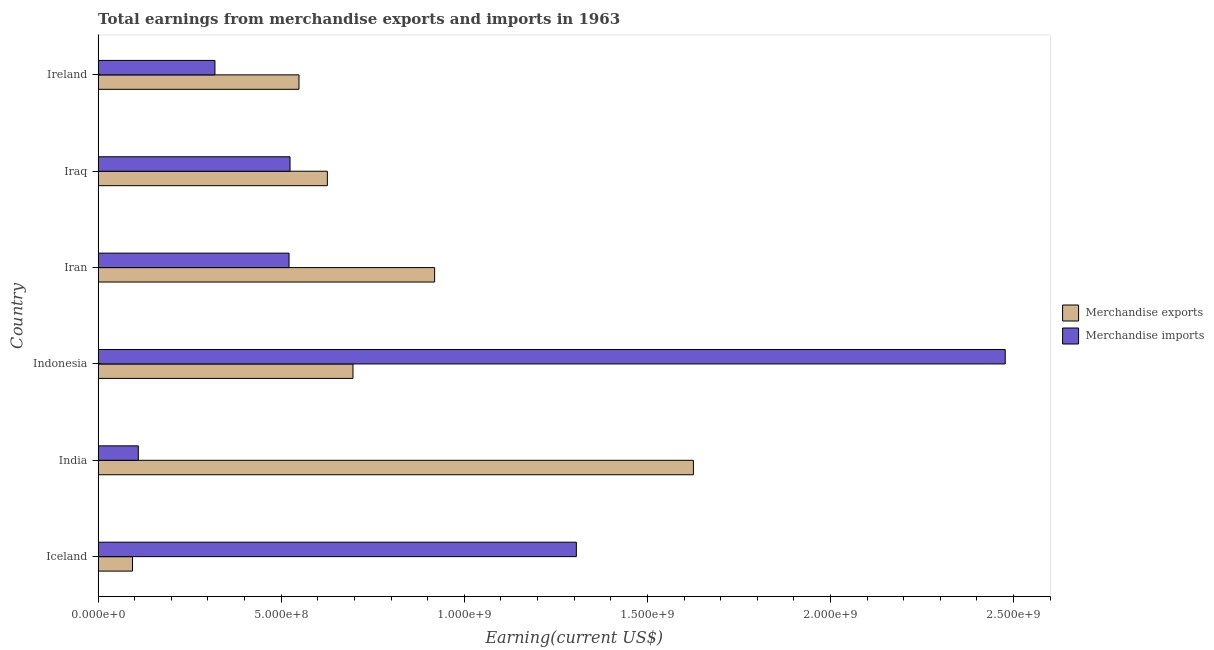Are the number of bars per tick equal to the number of legend labels?
Keep it short and to the point. Yes. How many bars are there on the 4th tick from the top?
Provide a short and direct response. 2. In how many cases, is the number of bars for a given country not equal to the number of legend labels?
Your response must be concise. 0. What is the earnings from merchandise exports in India?
Offer a very short reply. 1.63e+09. Across all countries, what is the maximum earnings from merchandise exports?
Offer a very short reply. 1.63e+09. Across all countries, what is the minimum earnings from merchandise imports?
Ensure brevity in your answer.  1.10e+08. What is the total earnings from merchandise exports in the graph?
Ensure brevity in your answer.  4.51e+09. What is the difference between the earnings from merchandise imports in Iran and that in Iraq?
Your answer should be very brief. -2.69e+06. What is the difference between the earnings from merchandise imports in Iceland and the earnings from merchandise exports in Iraq?
Provide a short and direct response. 6.80e+08. What is the average earnings from merchandise imports per country?
Ensure brevity in your answer.  8.76e+08. What is the difference between the earnings from merchandise imports and earnings from merchandise exports in Iraq?
Keep it short and to the point. -1.02e+08. In how many countries, is the earnings from merchandise exports greater than 600000000 US$?
Keep it short and to the point. 4. What is the ratio of the earnings from merchandise exports in India to that in Ireland?
Your response must be concise. 2.96. What is the difference between the highest and the second highest earnings from merchandise exports?
Your answer should be compact. 7.07e+08. What is the difference between the highest and the lowest earnings from merchandise imports?
Offer a very short reply. 2.37e+09. Is the sum of the earnings from merchandise imports in India and Iraq greater than the maximum earnings from merchandise exports across all countries?
Provide a short and direct response. No. What does the 1st bar from the bottom in India represents?
Offer a terse response. Merchandise exports. How many bars are there?
Offer a terse response. 12. Are all the bars in the graph horizontal?
Your response must be concise. Yes. Does the graph contain any zero values?
Provide a succinct answer. No. Does the graph contain grids?
Offer a very short reply. No. How are the legend labels stacked?
Offer a very short reply. Vertical. What is the title of the graph?
Give a very brief answer. Total earnings from merchandise exports and imports in 1963. What is the label or title of the X-axis?
Your response must be concise. Earning(current US$). What is the Earning(current US$) in Merchandise exports in Iceland?
Offer a very short reply. 9.40e+07. What is the Earning(current US$) in Merchandise imports in Iceland?
Provide a succinct answer. 1.31e+09. What is the Earning(current US$) of Merchandise exports in India?
Make the answer very short. 1.63e+09. What is the Earning(current US$) in Merchandise imports in India?
Provide a succinct answer. 1.10e+08. What is the Earning(current US$) of Merchandise exports in Indonesia?
Provide a succinct answer. 6.96e+08. What is the Earning(current US$) in Merchandise imports in Indonesia?
Your answer should be very brief. 2.48e+09. What is the Earning(current US$) of Merchandise exports in Iran?
Provide a succinct answer. 9.19e+08. What is the Earning(current US$) in Merchandise imports in Iran?
Provide a short and direct response. 5.21e+08. What is the Earning(current US$) in Merchandise exports in Iraq?
Ensure brevity in your answer.  6.26e+08. What is the Earning(current US$) in Merchandise imports in Iraq?
Ensure brevity in your answer.  5.24e+08. What is the Earning(current US$) in Merchandise exports in Ireland?
Give a very brief answer. 5.49e+08. What is the Earning(current US$) of Merchandise imports in Ireland?
Your response must be concise. 3.19e+08. Across all countries, what is the maximum Earning(current US$) of Merchandise exports?
Provide a succinct answer. 1.63e+09. Across all countries, what is the maximum Earning(current US$) of Merchandise imports?
Keep it short and to the point. 2.48e+09. Across all countries, what is the minimum Earning(current US$) in Merchandise exports?
Keep it short and to the point. 9.40e+07. Across all countries, what is the minimum Earning(current US$) of Merchandise imports?
Give a very brief answer. 1.10e+08. What is the total Earning(current US$) in Merchandise exports in the graph?
Ensure brevity in your answer.  4.51e+09. What is the total Earning(current US$) in Merchandise imports in the graph?
Offer a terse response. 5.26e+09. What is the difference between the Earning(current US$) in Merchandise exports in Iceland and that in India?
Make the answer very short. -1.53e+09. What is the difference between the Earning(current US$) of Merchandise imports in Iceland and that in India?
Provide a succinct answer. 1.20e+09. What is the difference between the Earning(current US$) in Merchandise exports in Iceland and that in Indonesia?
Keep it short and to the point. -6.02e+08. What is the difference between the Earning(current US$) in Merchandise imports in Iceland and that in Indonesia?
Offer a terse response. -1.17e+09. What is the difference between the Earning(current US$) in Merchandise exports in Iceland and that in Iran?
Offer a very short reply. -8.25e+08. What is the difference between the Earning(current US$) in Merchandise imports in Iceland and that in Iran?
Give a very brief answer. 7.85e+08. What is the difference between the Earning(current US$) in Merchandise exports in Iceland and that in Iraq?
Provide a short and direct response. -5.32e+08. What is the difference between the Earning(current US$) in Merchandise imports in Iceland and that in Iraq?
Your answer should be very brief. 7.82e+08. What is the difference between the Earning(current US$) in Merchandise exports in Iceland and that in Ireland?
Your answer should be very brief. -4.55e+08. What is the difference between the Earning(current US$) of Merchandise imports in Iceland and that in Ireland?
Provide a short and direct response. 9.87e+08. What is the difference between the Earning(current US$) of Merchandise exports in India and that in Indonesia?
Give a very brief answer. 9.30e+08. What is the difference between the Earning(current US$) in Merchandise imports in India and that in Indonesia?
Make the answer very short. -2.37e+09. What is the difference between the Earning(current US$) in Merchandise exports in India and that in Iran?
Provide a short and direct response. 7.07e+08. What is the difference between the Earning(current US$) in Merchandise imports in India and that in Iran?
Make the answer very short. -4.12e+08. What is the difference between the Earning(current US$) of Merchandise exports in India and that in Iraq?
Your answer should be very brief. 1.00e+09. What is the difference between the Earning(current US$) in Merchandise imports in India and that in Iraq?
Ensure brevity in your answer.  -4.14e+08. What is the difference between the Earning(current US$) of Merchandise exports in India and that in Ireland?
Offer a very short reply. 1.08e+09. What is the difference between the Earning(current US$) in Merchandise imports in India and that in Ireland?
Offer a very short reply. -2.09e+08. What is the difference between the Earning(current US$) of Merchandise exports in Indonesia and that in Iran?
Provide a succinct answer. -2.23e+08. What is the difference between the Earning(current US$) in Merchandise imports in Indonesia and that in Iran?
Make the answer very short. 1.96e+09. What is the difference between the Earning(current US$) of Merchandise exports in Indonesia and that in Iraq?
Offer a terse response. 7.00e+07. What is the difference between the Earning(current US$) in Merchandise imports in Indonesia and that in Iraq?
Provide a short and direct response. 1.95e+09. What is the difference between the Earning(current US$) in Merchandise exports in Indonesia and that in Ireland?
Ensure brevity in your answer.  1.47e+08. What is the difference between the Earning(current US$) of Merchandise imports in Indonesia and that in Ireland?
Your response must be concise. 2.16e+09. What is the difference between the Earning(current US$) of Merchandise exports in Iran and that in Iraq?
Give a very brief answer. 2.93e+08. What is the difference between the Earning(current US$) in Merchandise imports in Iran and that in Iraq?
Give a very brief answer. -2.69e+06. What is the difference between the Earning(current US$) of Merchandise exports in Iran and that in Ireland?
Your answer should be compact. 3.70e+08. What is the difference between the Earning(current US$) in Merchandise imports in Iran and that in Ireland?
Your answer should be compact. 2.02e+08. What is the difference between the Earning(current US$) of Merchandise exports in Iraq and that in Ireland?
Provide a succinct answer. 7.75e+07. What is the difference between the Earning(current US$) in Merchandise imports in Iraq and that in Ireland?
Provide a short and direct response. 2.05e+08. What is the difference between the Earning(current US$) in Merchandise exports in Iceland and the Earning(current US$) in Merchandise imports in India?
Offer a very short reply. -1.58e+07. What is the difference between the Earning(current US$) of Merchandise exports in Iceland and the Earning(current US$) of Merchandise imports in Indonesia?
Your response must be concise. -2.38e+09. What is the difference between the Earning(current US$) of Merchandise exports in Iceland and the Earning(current US$) of Merchandise imports in Iran?
Offer a terse response. -4.27e+08. What is the difference between the Earning(current US$) of Merchandise exports in Iceland and the Earning(current US$) of Merchandise imports in Iraq?
Ensure brevity in your answer.  -4.30e+08. What is the difference between the Earning(current US$) of Merchandise exports in Iceland and the Earning(current US$) of Merchandise imports in Ireland?
Give a very brief answer. -2.25e+08. What is the difference between the Earning(current US$) of Merchandise exports in India and the Earning(current US$) of Merchandise imports in Indonesia?
Make the answer very short. -8.52e+08. What is the difference between the Earning(current US$) in Merchandise exports in India and the Earning(current US$) in Merchandise imports in Iran?
Your answer should be very brief. 1.10e+09. What is the difference between the Earning(current US$) in Merchandise exports in India and the Earning(current US$) in Merchandise imports in Iraq?
Provide a short and direct response. 1.10e+09. What is the difference between the Earning(current US$) in Merchandise exports in India and the Earning(current US$) in Merchandise imports in Ireland?
Your response must be concise. 1.31e+09. What is the difference between the Earning(current US$) of Merchandise exports in Indonesia and the Earning(current US$) of Merchandise imports in Iran?
Provide a short and direct response. 1.75e+08. What is the difference between the Earning(current US$) of Merchandise exports in Indonesia and the Earning(current US$) of Merchandise imports in Iraq?
Offer a terse response. 1.72e+08. What is the difference between the Earning(current US$) of Merchandise exports in Indonesia and the Earning(current US$) of Merchandise imports in Ireland?
Provide a succinct answer. 3.77e+08. What is the difference between the Earning(current US$) of Merchandise exports in Iran and the Earning(current US$) of Merchandise imports in Iraq?
Give a very brief answer. 3.95e+08. What is the difference between the Earning(current US$) in Merchandise exports in Iran and the Earning(current US$) in Merchandise imports in Ireland?
Keep it short and to the point. 6.00e+08. What is the difference between the Earning(current US$) of Merchandise exports in Iraq and the Earning(current US$) of Merchandise imports in Ireland?
Give a very brief answer. 3.07e+08. What is the average Earning(current US$) in Merchandise exports per country?
Give a very brief answer. 7.52e+08. What is the average Earning(current US$) in Merchandise imports per country?
Keep it short and to the point. 8.76e+08. What is the difference between the Earning(current US$) in Merchandise exports and Earning(current US$) in Merchandise imports in Iceland?
Offer a terse response. -1.21e+09. What is the difference between the Earning(current US$) in Merchandise exports and Earning(current US$) in Merchandise imports in India?
Ensure brevity in your answer.  1.52e+09. What is the difference between the Earning(current US$) in Merchandise exports and Earning(current US$) in Merchandise imports in Indonesia?
Your response must be concise. -1.78e+09. What is the difference between the Earning(current US$) in Merchandise exports and Earning(current US$) in Merchandise imports in Iran?
Provide a succinct answer. 3.98e+08. What is the difference between the Earning(current US$) of Merchandise exports and Earning(current US$) of Merchandise imports in Iraq?
Provide a succinct answer. 1.02e+08. What is the difference between the Earning(current US$) in Merchandise exports and Earning(current US$) in Merchandise imports in Ireland?
Your response must be concise. 2.30e+08. What is the ratio of the Earning(current US$) of Merchandise exports in Iceland to that in India?
Keep it short and to the point. 0.06. What is the ratio of the Earning(current US$) of Merchandise imports in Iceland to that in India?
Offer a very short reply. 11.9. What is the ratio of the Earning(current US$) in Merchandise exports in Iceland to that in Indonesia?
Give a very brief answer. 0.14. What is the ratio of the Earning(current US$) of Merchandise imports in Iceland to that in Indonesia?
Provide a short and direct response. 0.53. What is the ratio of the Earning(current US$) in Merchandise exports in Iceland to that in Iran?
Keep it short and to the point. 0.1. What is the ratio of the Earning(current US$) in Merchandise imports in Iceland to that in Iran?
Your answer should be very brief. 2.5. What is the ratio of the Earning(current US$) in Merchandise exports in Iceland to that in Iraq?
Your response must be concise. 0.15. What is the ratio of the Earning(current US$) in Merchandise imports in Iceland to that in Iraq?
Provide a succinct answer. 2.49. What is the ratio of the Earning(current US$) in Merchandise exports in Iceland to that in Ireland?
Your answer should be very brief. 0.17. What is the ratio of the Earning(current US$) in Merchandise imports in Iceland to that in Ireland?
Your answer should be compact. 4.09. What is the ratio of the Earning(current US$) in Merchandise exports in India to that in Indonesia?
Your answer should be compact. 2.34. What is the ratio of the Earning(current US$) in Merchandise imports in India to that in Indonesia?
Offer a terse response. 0.04. What is the ratio of the Earning(current US$) of Merchandise exports in India to that in Iran?
Your response must be concise. 1.77. What is the ratio of the Earning(current US$) in Merchandise imports in India to that in Iran?
Give a very brief answer. 0.21. What is the ratio of the Earning(current US$) in Merchandise exports in India to that in Iraq?
Your answer should be compact. 2.6. What is the ratio of the Earning(current US$) of Merchandise imports in India to that in Iraq?
Ensure brevity in your answer.  0.21. What is the ratio of the Earning(current US$) in Merchandise exports in India to that in Ireland?
Your answer should be very brief. 2.96. What is the ratio of the Earning(current US$) of Merchandise imports in India to that in Ireland?
Provide a short and direct response. 0.34. What is the ratio of the Earning(current US$) of Merchandise exports in Indonesia to that in Iran?
Your response must be concise. 0.76. What is the ratio of the Earning(current US$) in Merchandise imports in Indonesia to that in Iran?
Your response must be concise. 4.75. What is the ratio of the Earning(current US$) in Merchandise exports in Indonesia to that in Iraq?
Offer a terse response. 1.11. What is the ratio of the Earning(current US$) in Merchandise imports in Indonesia to that in Iraq?
Make the answer very short. 4.73. What is the ratio of the Earning(current US$) in Merchandise exports in Indonesia to that in Ireland?
Keep it short and to the point. 1.27. What is the ratio of the Earning(current US$) in Merchandise imports in Indonesia to that in Ireland?
Ensure brevity in your answer.  7.77. What is the ratio of the Earning(current US$) in Merchandise exports in Iran to that in Iraq?
Offer a very short reply. 1.47. What is the ratio of the Earning(current US$) of Merchandise imports in Iran to that in Iraq?
Your answer should be very brief. 0.99. What is the ratio of the Earning(current US$) of Merchandise exports in Iran to that in Ireland?
Provide a succinct answer. 1.68. What is the ratio of the Earning(current US$) in Merchandise imports in Iran to that in Ireland?
Ensure brevity in your answer.  1.63. What is the ratio of the Earning(current US$) of Merchandise exports in Iraq to that in Ireland?
Make the answer very short. 1.14. What is the ratio of the Earning(current US$) of Merchandise imports in Iraq to that in Ireland?
Your answer should be very brief. 1.64. What is the difference between the highest and the second highest Earning(current US$) in Merchandise exports?
Provide a short and direct response. 7.07e+08. What is the difference between the highest and the second highest Earning(current US$) of Merchandise imports?
Your answer should be compact. 1.17e+09. What is the difference between the highest and the lowest Earning(current US$) in Merchandise exports?
Provide a short and direct response. 1.53e+09. What is the difference between the highest and the lowest Earning(current US$) of Merchandise imports?
Your response must be concise. 2.37e+09. 